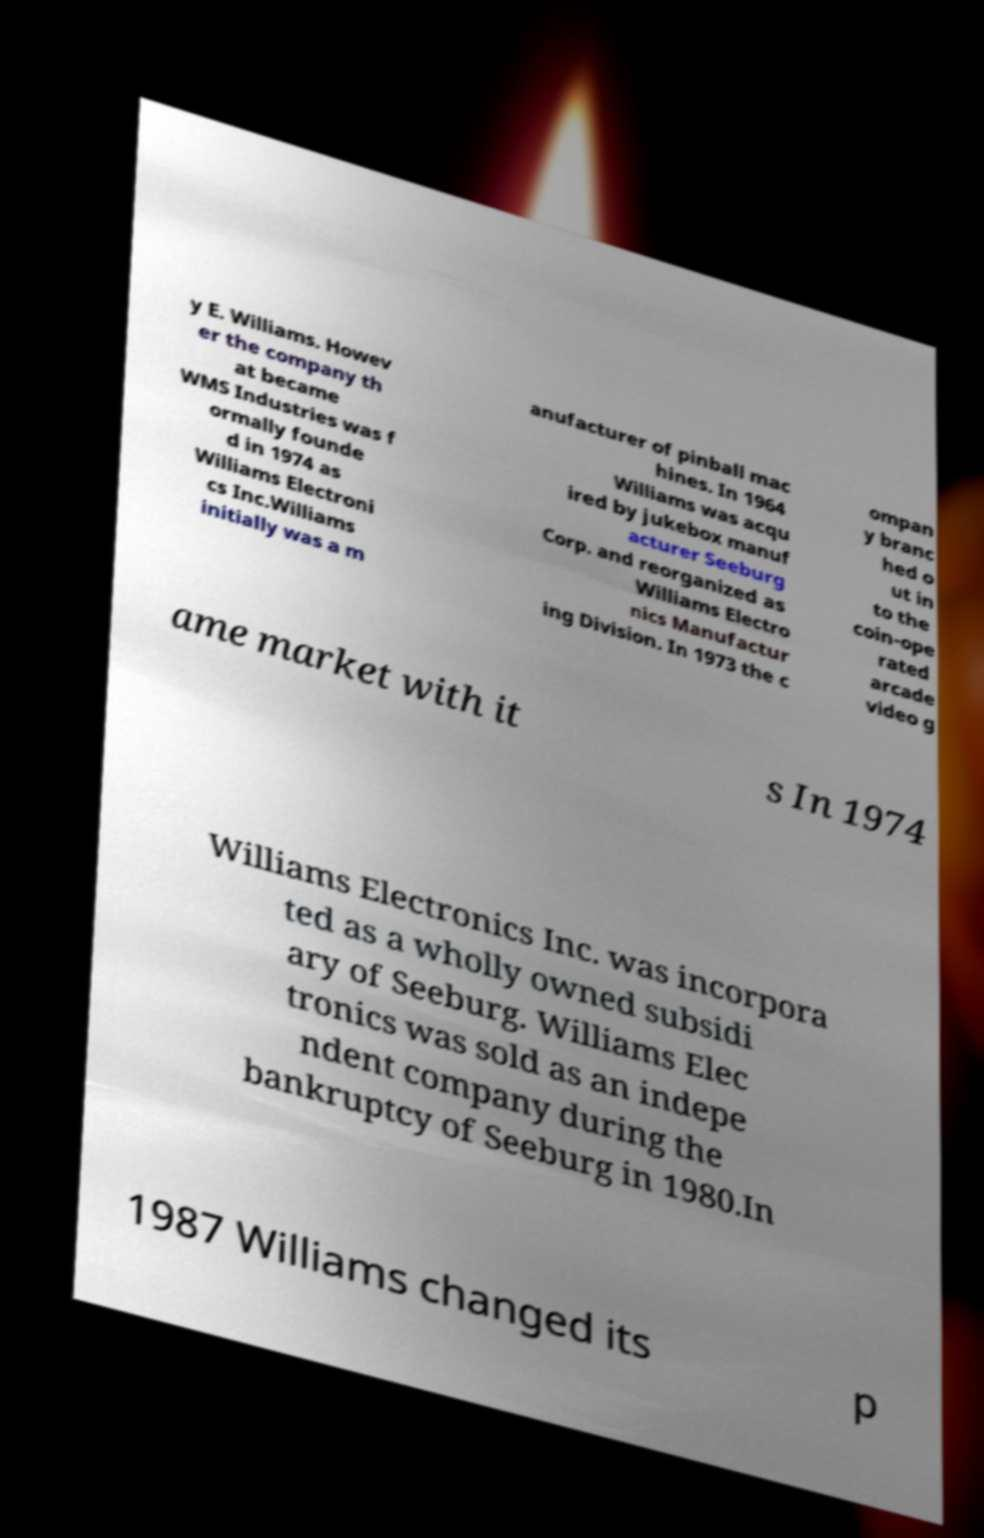Please read and relay the text visible in this image. What does it say? y E. Williams. Howev er the company th at became WMS Industries was f ormally founde d in 1974 as Williams Electroni cs Inc.Williams initially was a m anufacturer of pinball mac hines. In 1964 Williams was acqu ired by jukebox manuf acturer Seeburg Corp. and reorganized as Williams Electro nics Manufactur ing Division. In 1973 the c ompan y branc hed o ut in to the coin-ope rated arcade video g ame market with it s In 1974 Williams Electronics Inc. was incorpora ted as a wholly owned subsidi ary of Seeburg. Williams Elec tronics was sold as an indepe ndent company during the bankruptcy of Seeburg in 1980.In 1987 Williams changed its p 